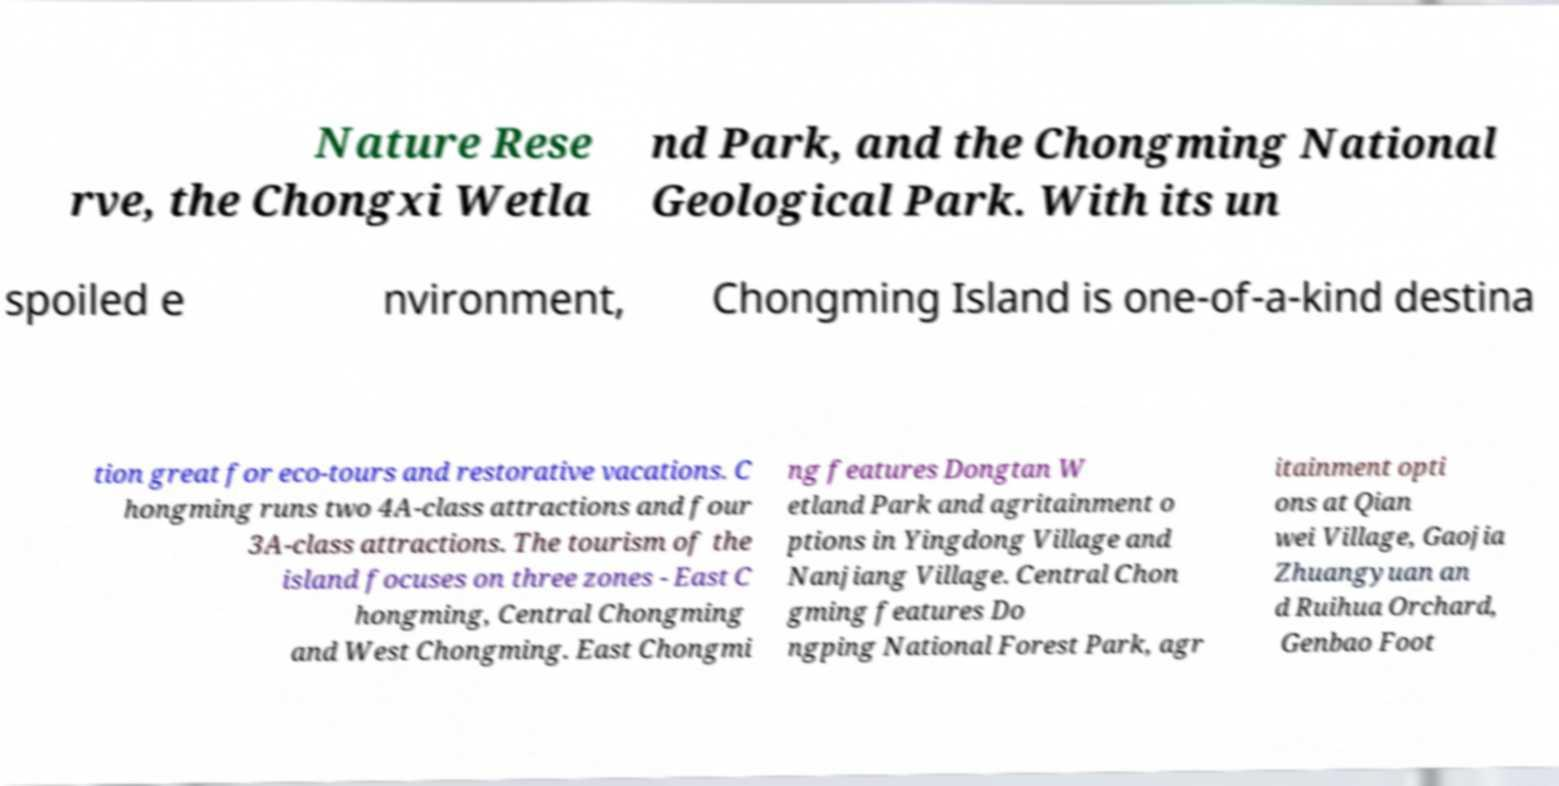Could you assist in decoding the text presented in this image and type it out clearly? Nature Rese rve, the Chongxi Wetla nd Park, and the Chongming National Geological Park. With its un spoiled e nvironment, Chongming Island is one-of-a-kind destina tion great for eco-tours and restorative vacations. C hongming runs two 4A-class attractions and four 3A-class attractions. The tourism of the island focuses on three zones - East C hongming, Central Chongming and West Chongming. East Chongmi ng features Dongtan W etland Park and agritainment o ptions in Yingdong Village and Nanjiang Village. Central Chon gming features Do ngping National Forest Park, agr itainment opti ons at Qian wei Village, Gaojia Zhuangyuan an d Ruihua Orchard, Genbao Foot 